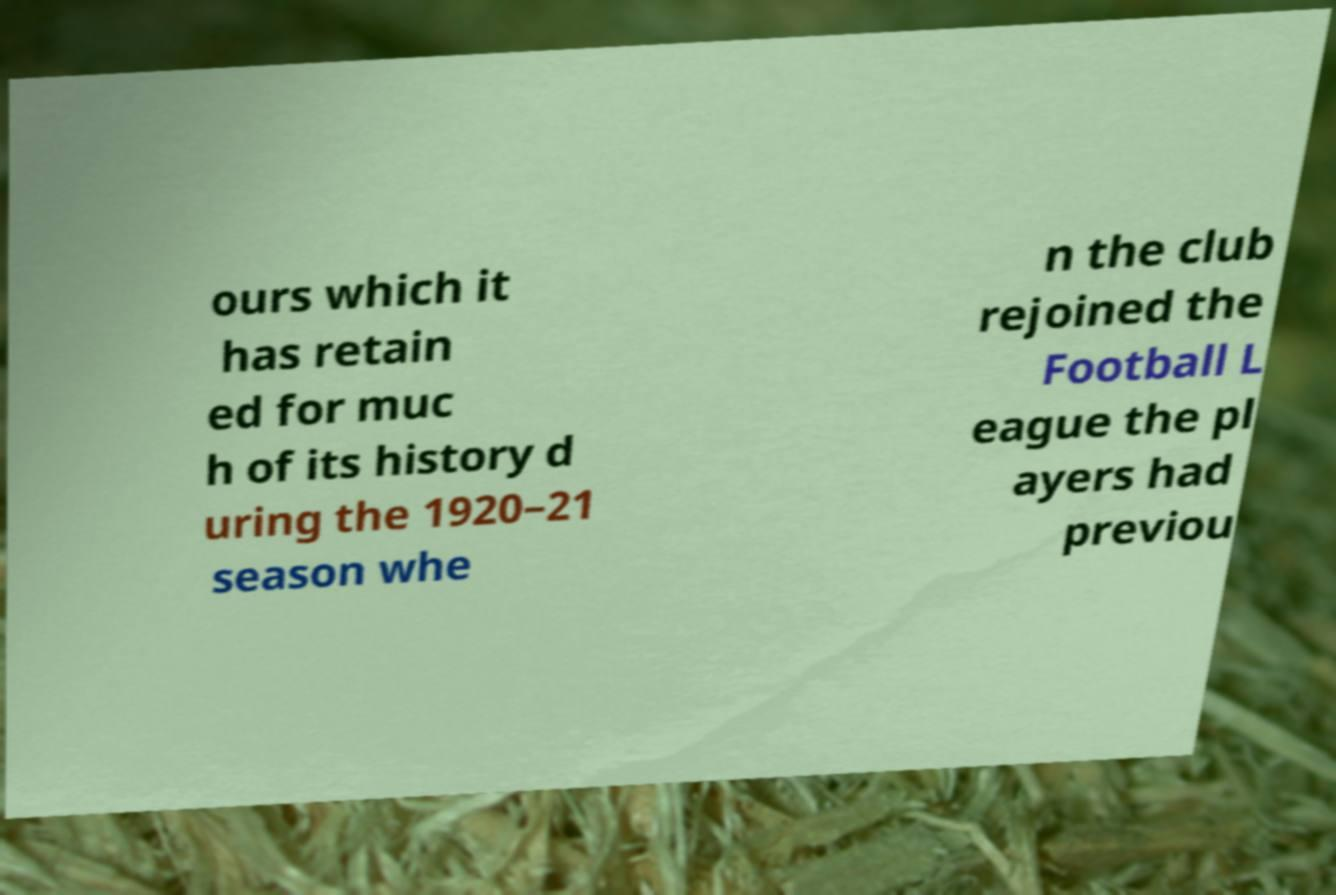Can you accurately transcribe the text from the provided image for me? ours which it has retain ed for muc h of its history d uring the 1920–21 season whe n the club rejoined the Football L eague the pl ayers had previou 